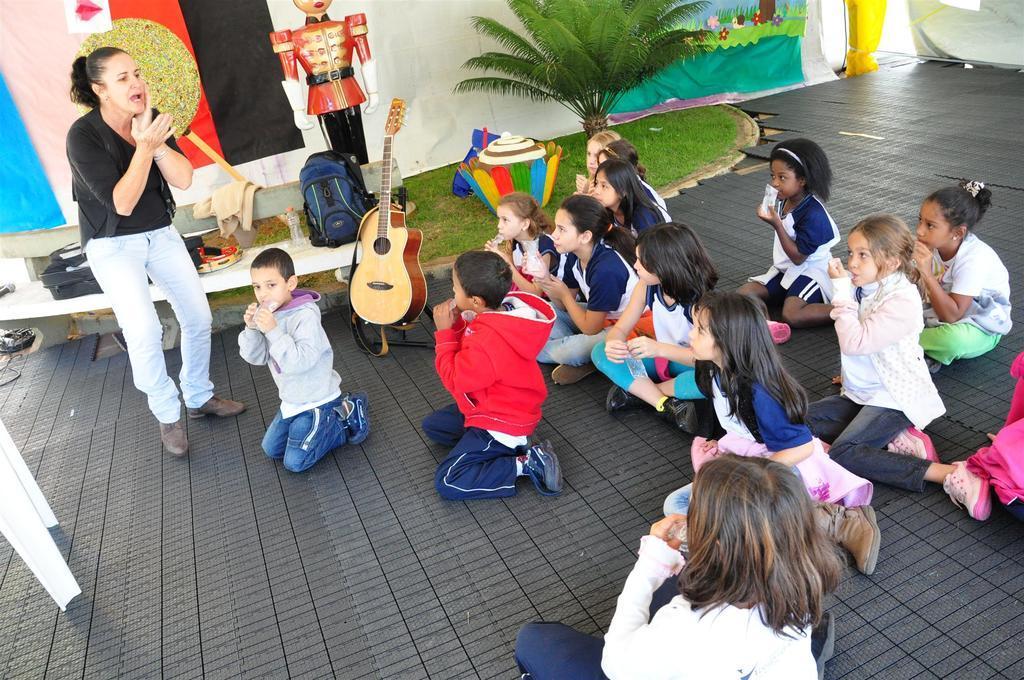Can you describe this image briefly? In this image we can see children sitting and a woman standing on the floor. In the background we can see doll, backpacks, disposal bottles, ground, plants and a musical instrument. 